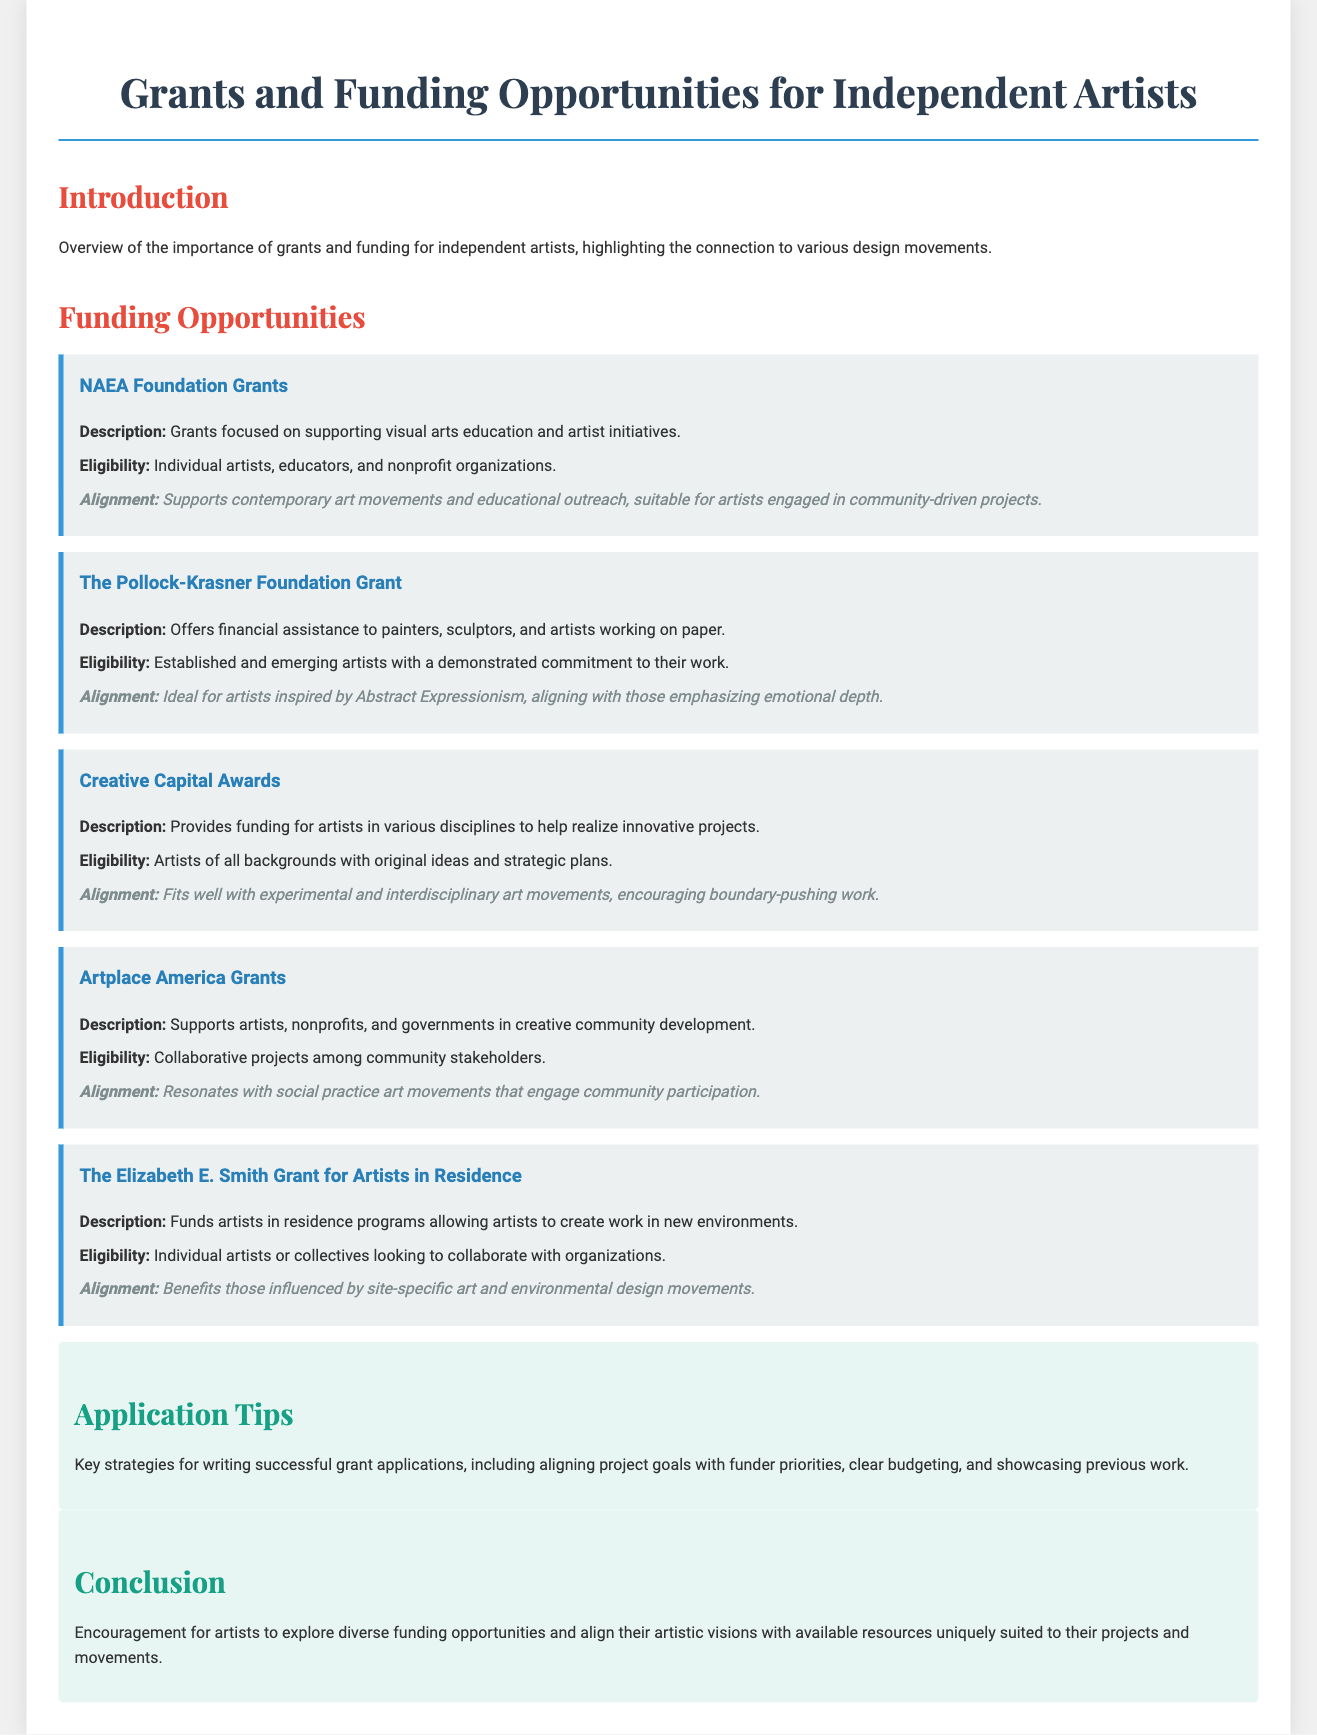What is the title of the document? The title, as stated at the top of the document, is "Grants and Funding Opportunities for Independent Artists."
Answer: Grants and Funding Opportunities for Independent Artists How many funding opportunities are listed? The document lists five different funding opportunities under the "Funding Opportunities" section.
Answer: 5 What is the eligibility for the NAEA Foundation Grants? The eligibility criteria for the NAEA Foundation Grants includes individual artists, educators, and nonprofit organizations.
Answer: Individual artists, educators, and nonprofit organizations Which grant is ideal for artists inspired by Abstract Expressionism? The grant that is ideal for artists inspired by Abstract Expressionism is "The Pollock-Krasner Foundation Grant."
Answer: The Pollock-Krasner Foundation Grant What type of projects do Artplace America Grants support? Artplace America Grants support "creative community development" projects involving artists, nonprofits, and governments.
Answer: Creative community development Which funding opportunity aligns with experimental and interdisciplinary art movements? The funding opportunity that aligns with experimental and interdisciplinary art movements is the "Creative Capital Awards."
Answer: Creative Capital Awards What is a key strategy for writing successful grant applications? One of the key strategies for writing successful grant applications is aligning project goals with funder priorities.
Answer: Aligning project goals with funder priorities What movement does The Elizabeth E. Smith Grant support? The Elizabeth E. Smith Grant benefits those influenced by "site-specific art and environmental design movements."
Answer: Site-specific art and environmental design movements What color is used for the section headers in this document? The section headers in the document are styled with a color that matches "dark blue."
Answer: Dark blue 